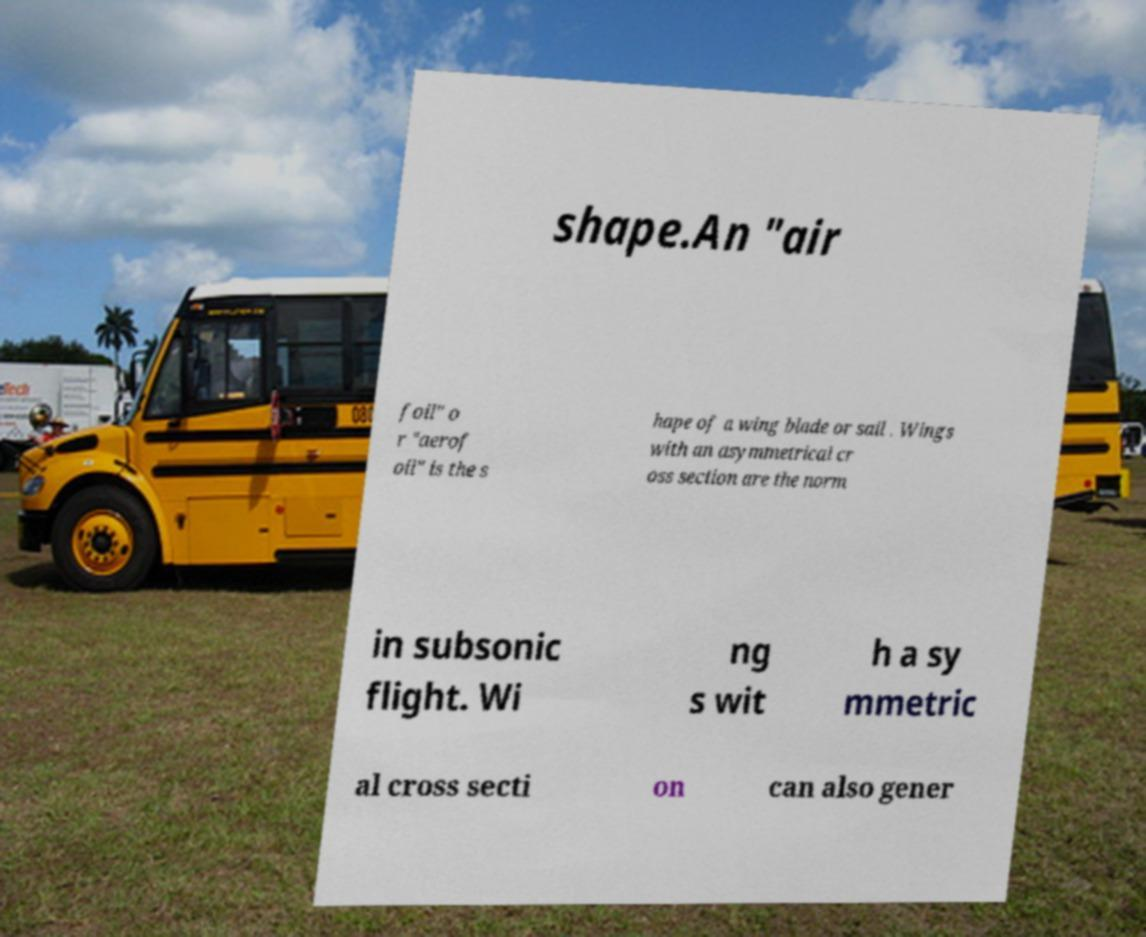Please identify and transcribe the text found in this image. shape.An "air foil" o r "aerof oil" is the s hape of a wing blade or sail . Wings with an asymmetrical cr oss section are the norm in subsonic flight. Wi ng s wit h a sy mmetric al cross secti on can also gener 